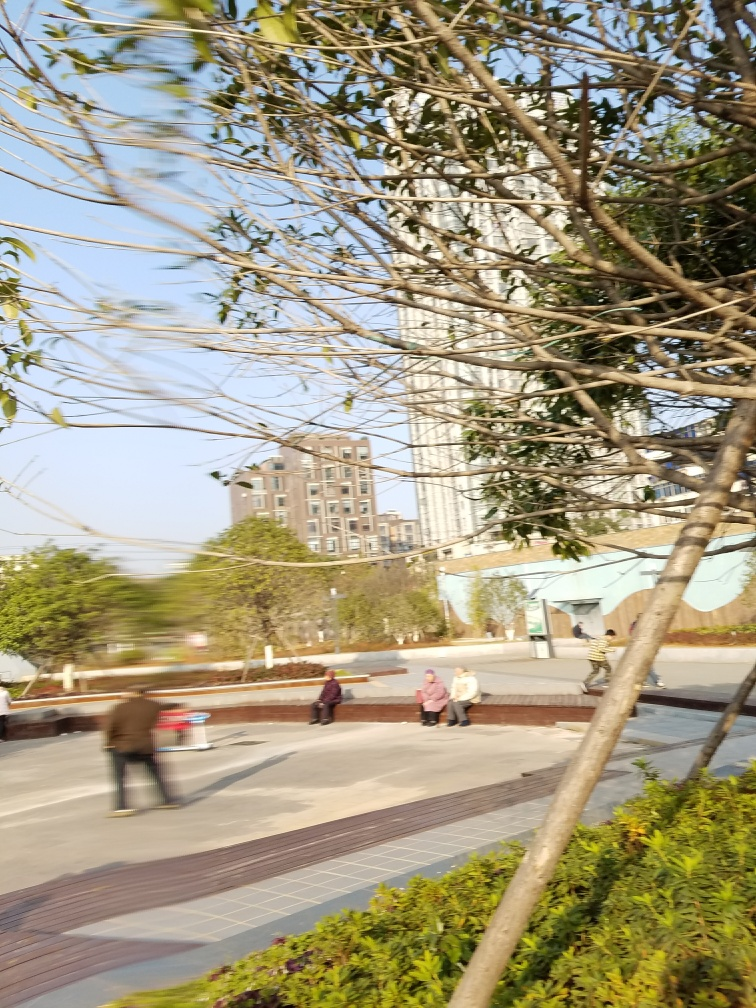Can you tell me more about the setting of this image? The image depicts an urban park setting where people are engaged in various activities. The park features manicured gardens with bushes and small trees, benches for seating, and a broad walkway. In the background, there are high-rise buildings, indicating that this park is likely situated within a modern city environment.  What is the approximate time of day in this image? Judging by the length of the shadows and the warm hue of the light, the image was taken either in the late afternoon or early evening when the sun is lower on the horizon, casting a golden light. 